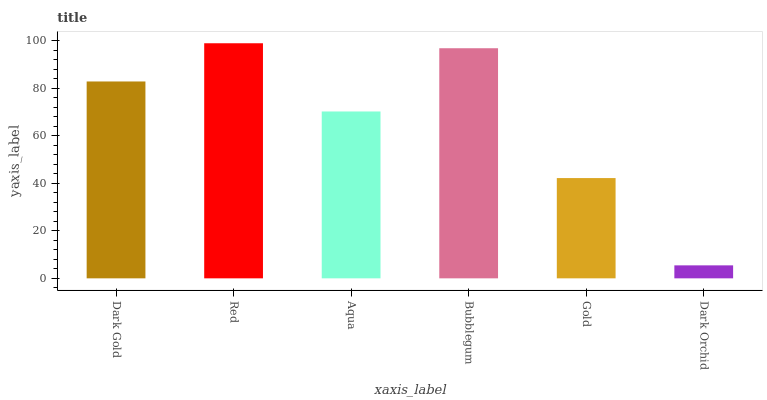Is Dark Orchid the minimum?
Answer yes or no. Yes. Is Red the maximum?
Answer yes or no. Yes. Is Aqua the minimum?
Answer yes or no. No. Is Aqua the maximum?
Answer yes or no. No. Is Red greater than Aqua?
Answer yes or no. Yes. Is Aqua less than Red?
Answer yes or no. Yes. Is Aqua greater than Red?
Answer yes or no. No. Is Red less than Aqua?
Answer yes or no. No. Is Dark Gold the high median?
Answer yes or no. Yes. Is Aqua the low median?
Answer yes or no. Yes. Is Gold the high median?
Answer yes or no. No. Is Dark Orchid the low median?
Answer yes or no. No. 